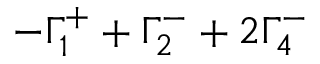Convert formula to latex. <formula><loc_0><loc_0><loc_500><loc_500>- \Gamma _ { 1 } ^ { + } + \Gamma _ { 2 } ^ { - } + 2 \Gamma _ { 4 } ^ { - }</formula> 